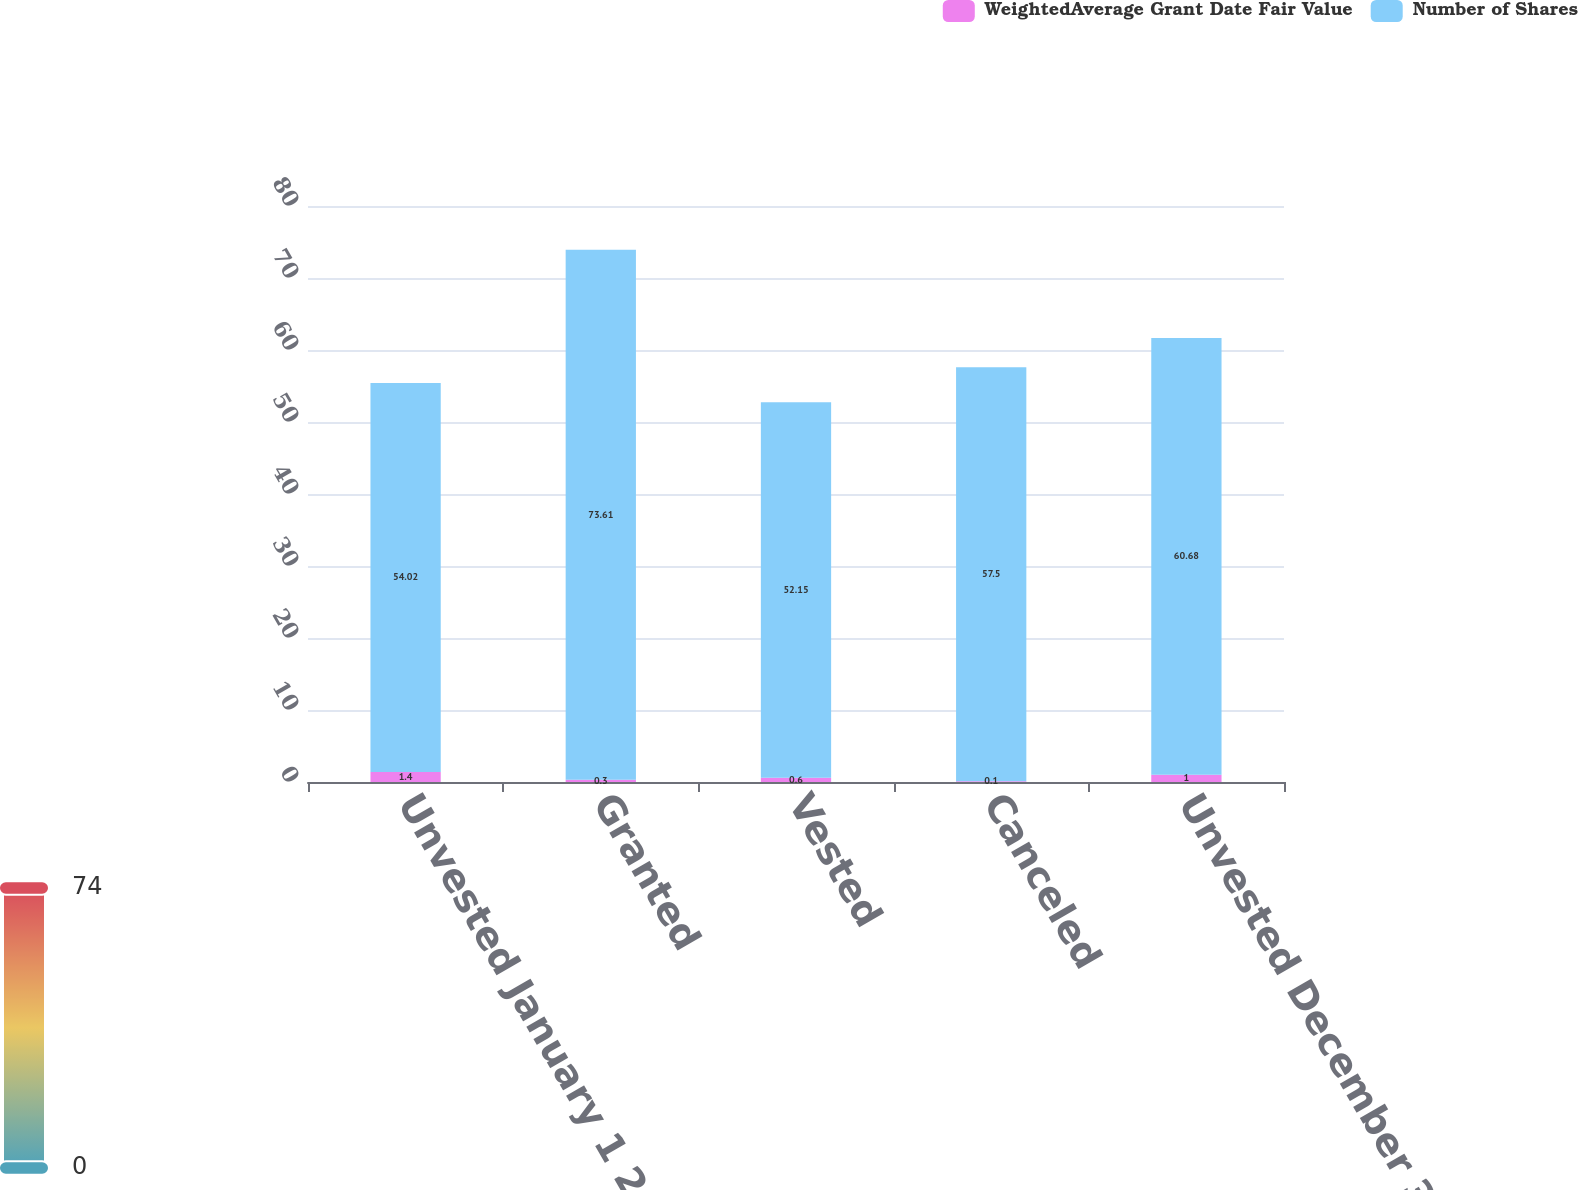Convert chart to OTSL. <chart><loc_0><loc_0><loc_500><loc_500><stacked_bar_chart><ecel><fcel>Unvested January 1 2014<fcel>Granted<fcel>Vested<fcel>Canceled<fcel>Unvested December 31 2014<nl><fcel>WeightedAverage Grant Date Fair Value<fcel>1.4<fcel>0.3<fcel>0.6<fcel>0.1<fcel>1<nl><fcel>Number of Shares<fcel>54.02<fcel>73.61<fcel>52.15<fcel>57.5<fcel>60.68<nl></chart> 